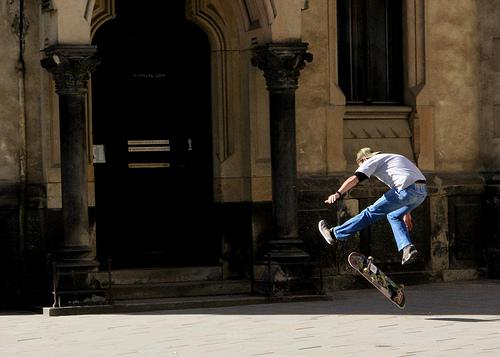Question: what is the focus?
Choices:
A. Bicyclist pedaling.
B. Snowboarder.
C. Skateboarder doing trick.
D. Unicycle rider.
Answer with the letter. Answer: C Question: how many skateboarders are shown?
Choices:
A. 2.
B. 1.
C. 3.
D. 4.
Answer with the letter. Answer: B Question: what type of trick is the skater doing?
Choices:
A. Ollie.
B. A speed race.
C. Flip trick.
D. Grinding.
Answer with the letter. Answer: C Question: what color is the skaters shirt?
Choices:
A. Black.
B. Grey.
C. White.
D. Blue.
Answer with the letter. Answer: C Question: how many animals are shown?
Choices:
A. 1.
B. 0.
C. 2.
D. 3.
Answer with the letter. Answer: B 